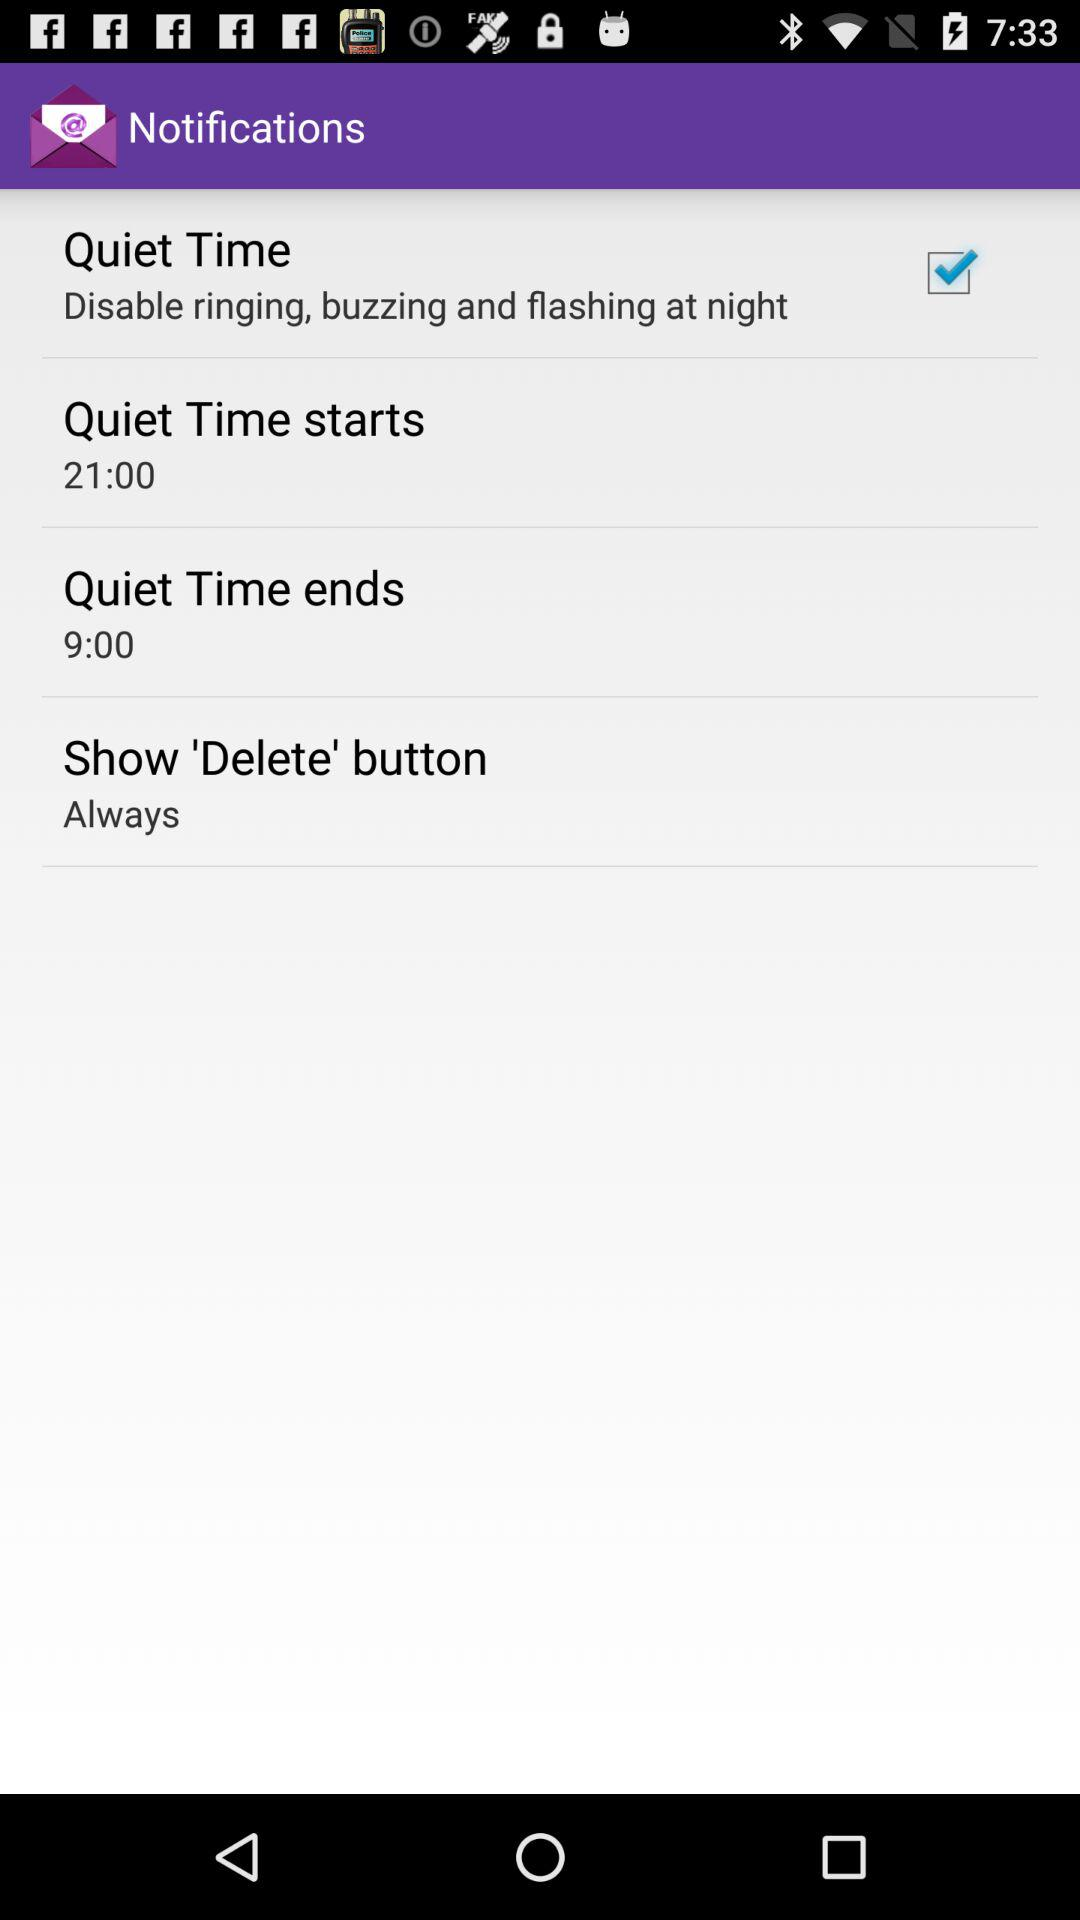What is the status of "Quiet Time"? The status of "Quiet Time" is "on". 